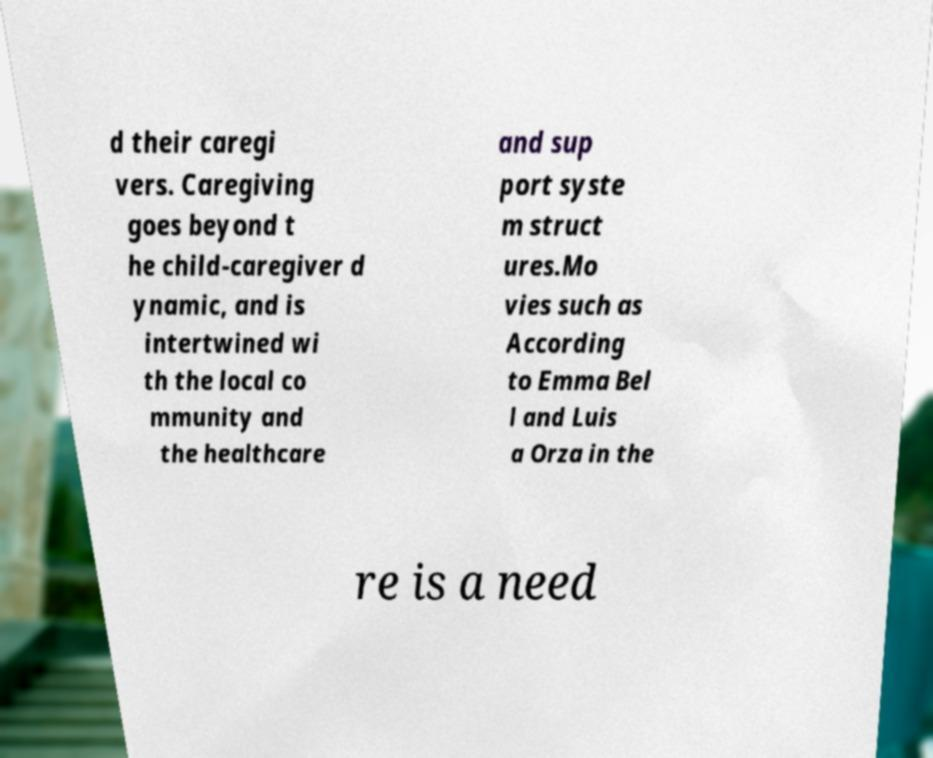Could you extract and type out the text from this image? d their caregi vers. Caregiving goes beyond t he child-caregiver d ynamic, and is intertwined wi th the local co mmunity and the healthcare and sup port syste m struct ures.Mo vies such as According to Emma Bel l and Luis a Orza in the re is a need 